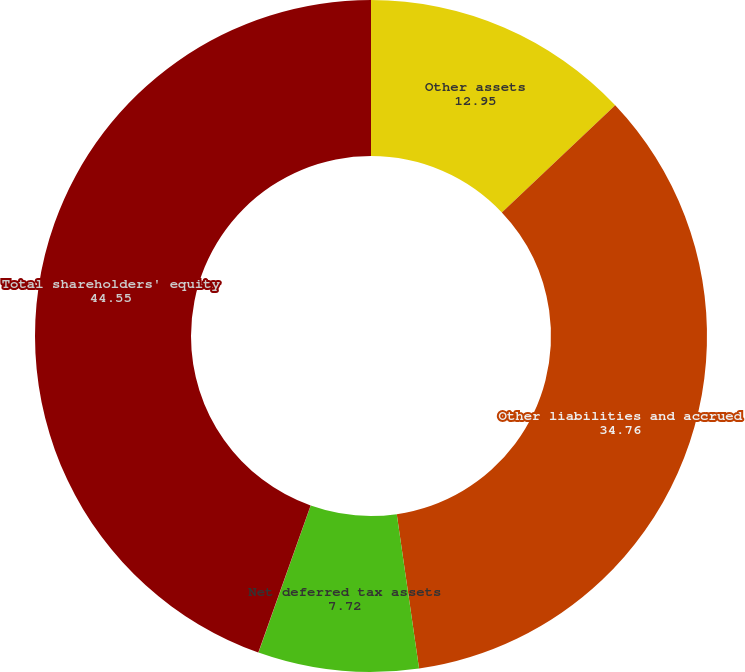Convert chart to OTSL. <chart><loc_0><loc_0><loc_500><loc_500><pie_chart><fcel>Other assets<fcel>Other liabilities and accrued<fcel>Net deferred tax assets<fcel>Accumulated other<fcel>Total shareholders' equity<nl><fcel>12.95%<fcel>34.76%<fcel>7.72%<fcel>0.01%<fcel>44.55%<nl></chart> 